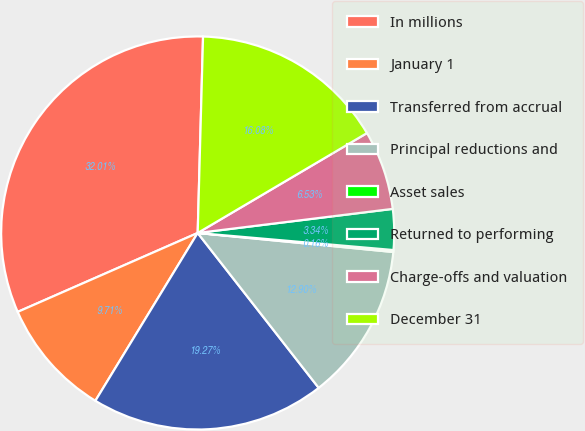Convert chart. <chart><loc_0><loc_0><loc_500><loc_500><pie_chart><fcel>In millions<fcel>January 1<fcel>Transferred from accrual<fcel>Principal reductions and<fcel>Asset sales<fcel>Returned to performing<fcel>Charge-offs and valuation<fcel>December 31<nl><fcel>32.01%<fcel>9.71%<fcel>19.27%<fcel>12.9%<fcel>0.16%<fcel>3.34%<fcel>6.53%<fcel>16.08%<nl></chart> 